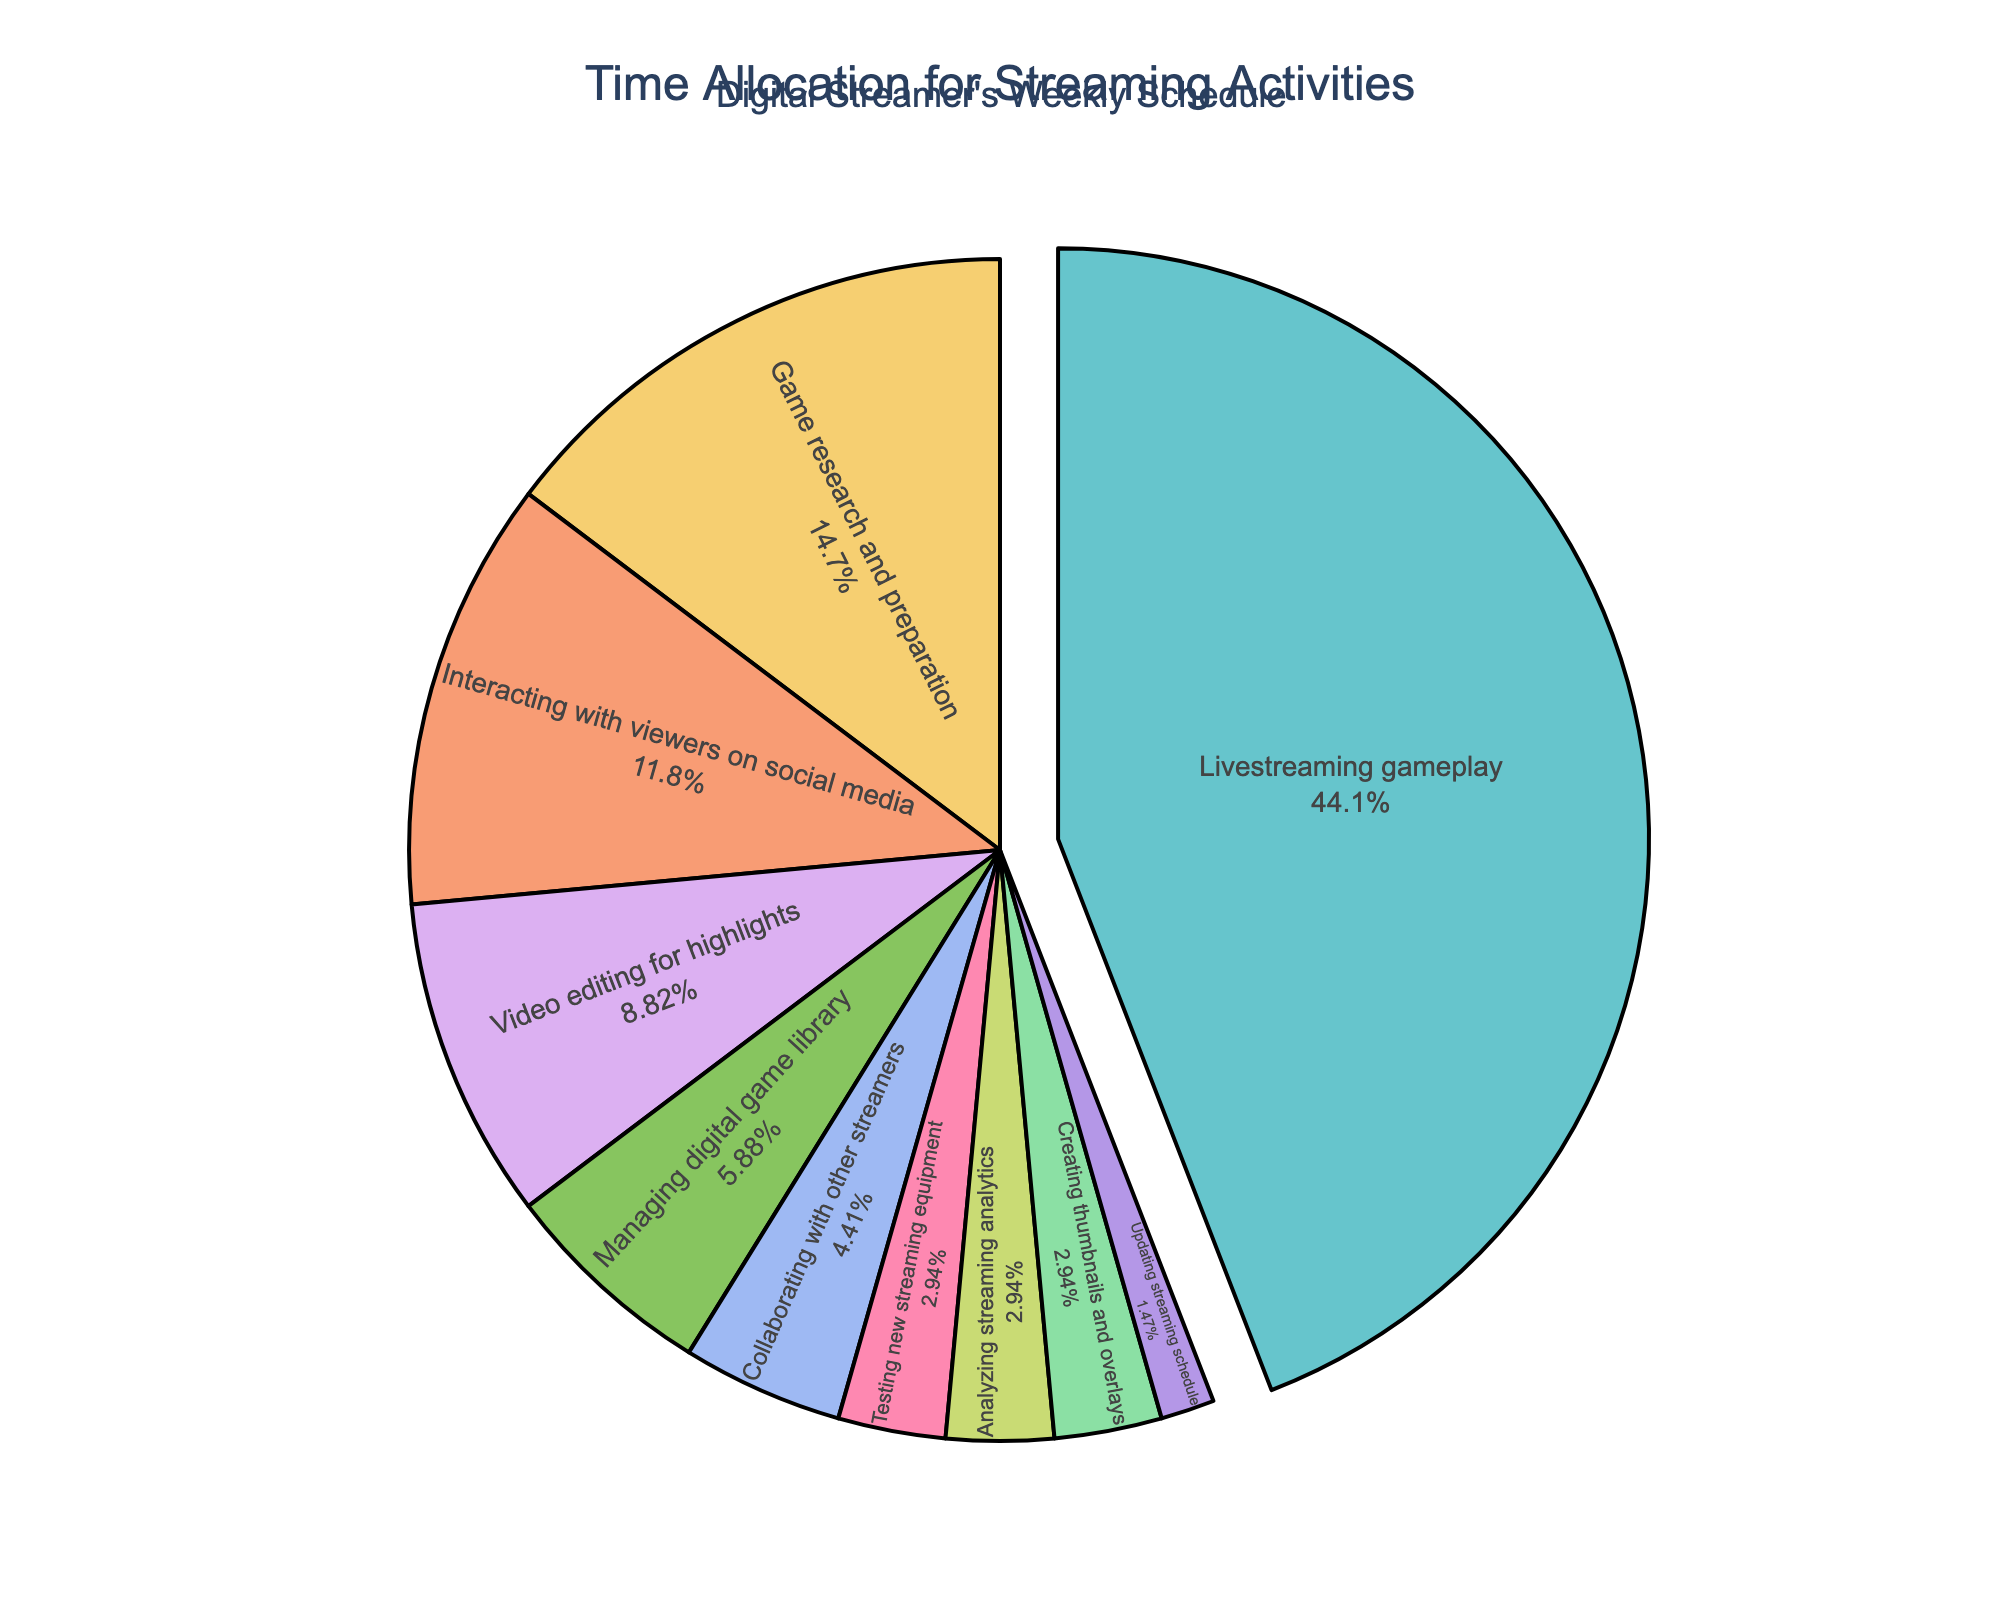What's the activity with the highest time allocation? The pie chart pulls out the segment representing the activity with the highest time allocation, which is labeled on the chart along with the percentage. By looking at the chart, we can see "Livestreaming gameplay" takes the largest segment with 30 hours per week.
Answer: Livestreaming gameplay How many hours per week are spent on video editing for highlights and creating thumbnails and overlays combined? From the pie chart, the hours for video editing for highlights is 6 and for creating thumbnails and overlays is 2. Add them together: 6 + 2 = 8 hours.
Answer: 8 hours What percentage of time is spent on testing new streaming equipment compared to updating the streaming schedule? The pie chart shows 2 hours for testing new streaming equipment and 1 hour for updating the streaming schedule. The percentages can be calculated as: (2 / 68) * 100 = 2.94% and (1 / 68) * 100 = 1.47%. Therefore, testing new streaming equipment takes about twice as much time as updating the streaming schedule.
Answer: 2.94% and 1.47% Which activities are allocated exactly 2 hours per week? The pie chart includes segments labeled with both the activity names and the number of hours. The activities allocated exactly 2 hours per week are "Testing new streaming equipment", "Analyzing streaming analytics", and "Creating thumbnails and overlays".
Answer: Testing new streaming equipment, Analyzing streaming analytics, Creating thumbnails and overlays What is the total percentage of time spent on interacting with viewers on social media and managing the digital game library? The pie chart shows 8 hours for interacting with viewers on social media and 4 hours for managing the digital game library. The total hours are 8 + 4 = 12. The percentage is (12 / 68) * 100 = 17.65%.
Answer: 17.65% How does the time spent on game research and preparation compare to collaborating with other streamers? The pie chart indicates 10 hours per week spent on game research and preparation and 3 hours on collaborating with other streamers. By comparing, we see more time is spent on game research and preparation (10 hours vs. 3 hours).
Answer: More time on game research and preparation What activity is associated with a yellow color in the pie chart, and how many hours are spent on it per week? Visual inspection of the pie chart shows the color coding for each activity. The yellow segment corresponds to "Interacting with viewers on social media" which is annotated with 8 hours per week.
Answer: Interacting with viewers on social media, 8 hours What's the sum of hours spent on the least allocated activities (activities with only 1 hour per week)? The pie chart shows that only "Updating streaming schedule" is allocated 1 hour per week. Therefore, sum = 1 hour.
Answer: 1 hour What is the difference in hours between the activity with the highest and the lowest time allocation? The pie chart displays 30 hours for "Livestreaming gameplay" (the highest) and 1 hour for "Updating streaming schedule" (the lowest). The difference is 30 - 1 = 29 hours.
Answer: 29 hours What percentage of time is allocated to managing the digital game library? The pie chart shows 4 hours are allocated to managing the digital game library. Convert this to a percentage of the total 68 hours: (4 / 68) * 100 = 5.88%.
Answer: 5.88% 